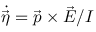<formula> <loc_0><loc_0><loc_500><loc_500>\dot { \vec { \eta } } = \vec { p } \times \vec { E } / I</formula> 